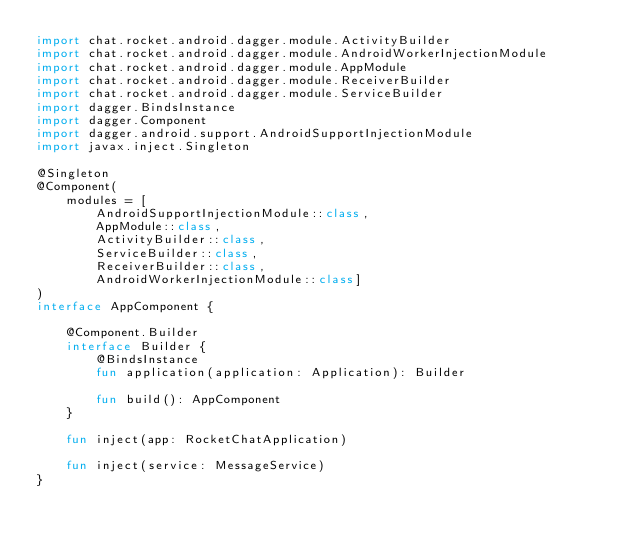<code> <loc_0><loc_0><loc_500><loc_500><_Kotlin_>import chat.rocket.android.dagger.module.ActivityBuilder
import chat.rocket.android.dagger.module.AndroidWorkerInjectionModule
import chat.rocket.android.dagger.module.AppModule
import chat.rocket.android.dagger.module.ReceiverBuilder
import chat.rocket.android.dagger.module.ServiceBuilder
import dagger.BindsInstance
import dagger.Component
import dagger.android.support.AndroidSupportInjectionModule
import javax.inject.Singleton

@Singleton
@Component(
    modules = [
        AndroidSupportInjectionModule::class,
        AppModule::class,
        ActivityBuilder::class,
        ServiceBuilder::class,
        ReceiverBuilder::class,
        AndroidWorkerInjectionModule::class]
)
interface AppComponent {

    @Component.Builder
    interface Builder {
        @BindsInstance
        fun application(application: Application): Builder

        fun build(): AppComponent
    }

    fun inject(app: RocketChatApplication)

    fun inject(service: MessageService)
}
</code> 